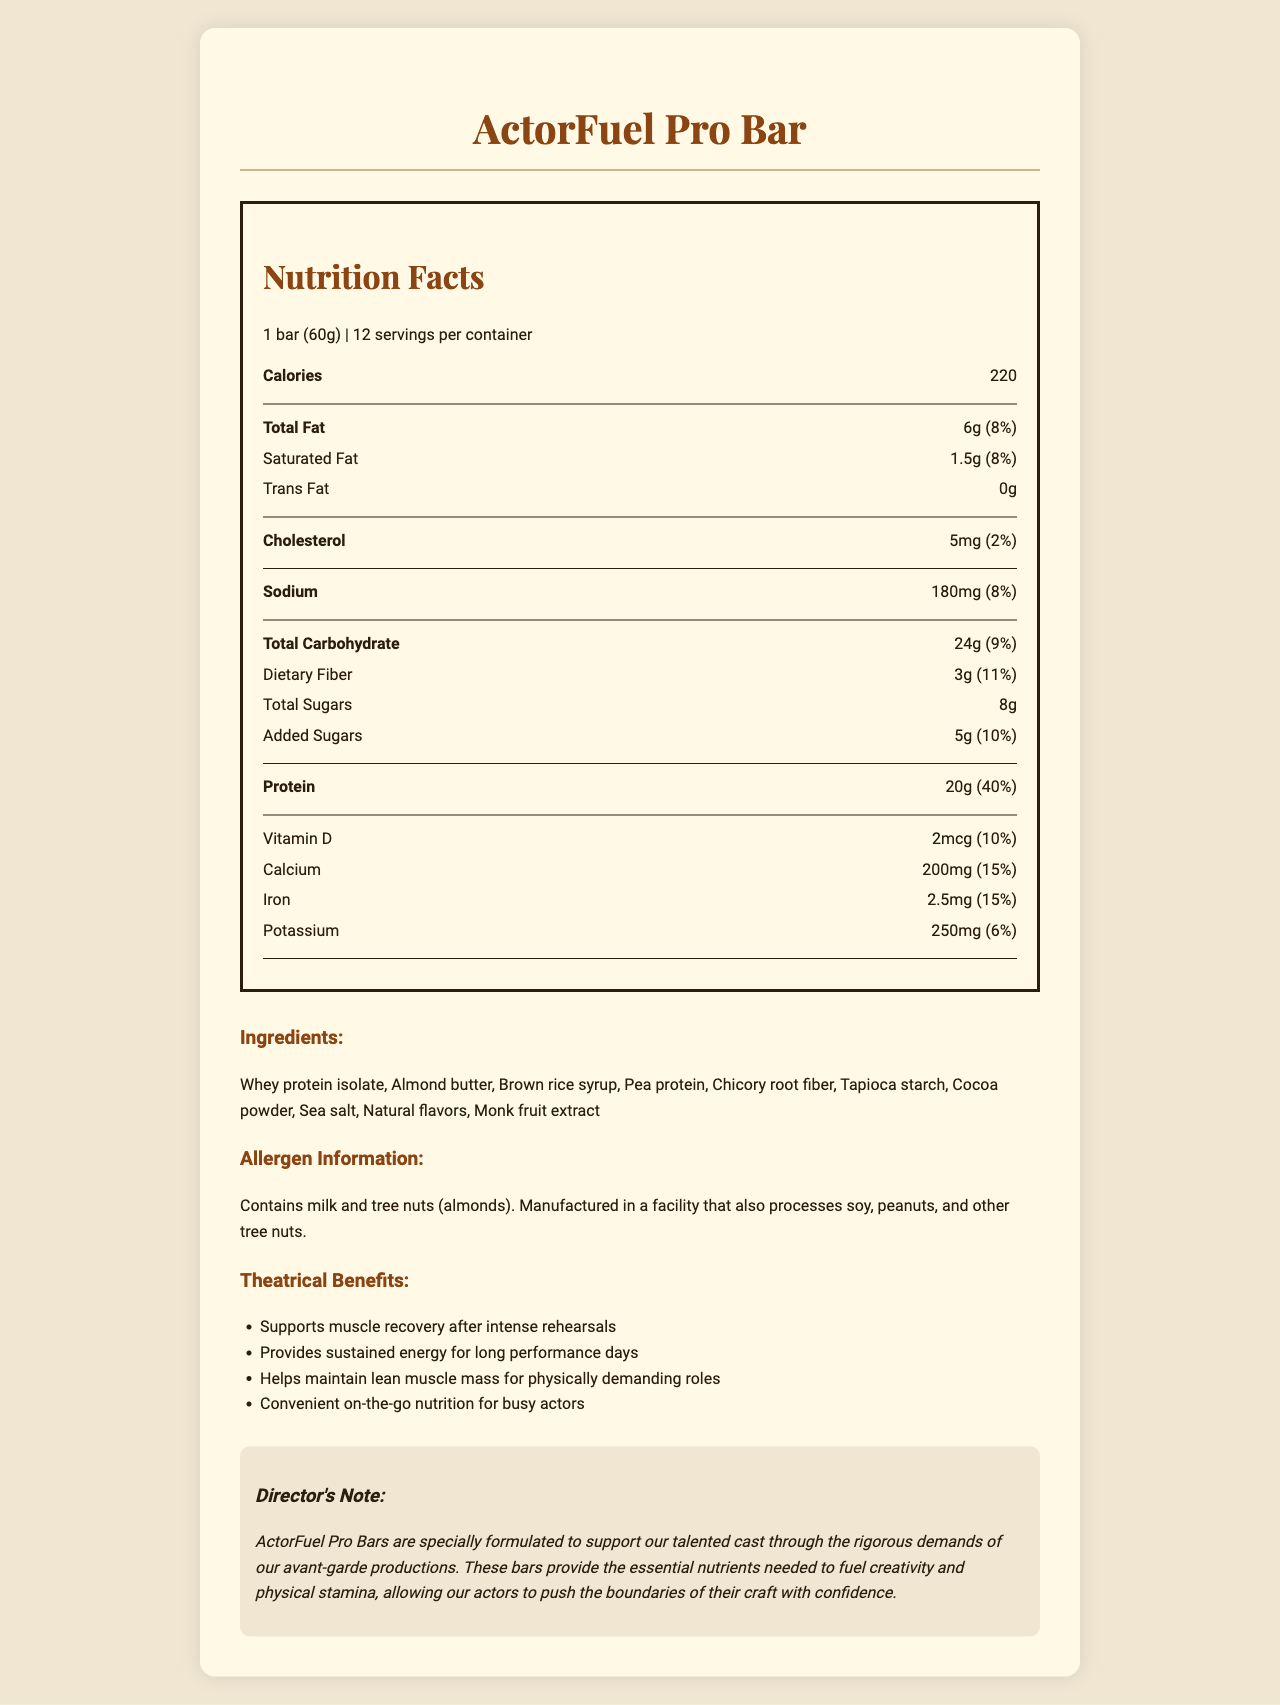what is the serving size of the ActorFuel Pro Bar? The serving size is clearly stated in the document as 1 bar (60g).
Answer: 1 bar (60g) how many servings are in each container of the ActorFuel Pro Bar? The document specifies that each container holds 12 servings.
Answer: 12 how much protein does each bar contain? The document lists the protein content as 20g per serving.
Answer: 20g What is the primary protein source listed in the ingredients? In the ingredients list, whey protein isolate is the primary source of protein.
Answer: Whey protein isolate What is the total amount of carbohydrates in one serving of the ActorFuel Pro Bar? The total carbohydrate content per serving is stated as 24g.
Answer: 24g how much dietary fiber is in one serving of the bar? The dietary fiber content is given as 3g per serving.
Answer: 3g what percentage of daily value of protein does the bar provide? The document lists the daily value percentage of protein as 40%.
Answer: 40% which of the following ingredients is NOT in the ActorFuel Pro Bar? A. Almond butter B. Pea protein C. Soy Protein The ingredient list includes almond butter and pea protein, but not soy protein.
Answer: C. Soy Protein What amount of Potassium does each serving of the ActorFuel Pro Bar contain? A. 200mg B. 250mg C. 300mg The document states that each serving contains 250mg of potassium.
Answer: B True or False: The ActorFuel Pro Bar contains trans fat. The document specifically lists trans fat as 0g, meaning it does not contain trans fat.
Answer: False Summarize the main idea of the document. The document focuses on how the ActorFuel Pro Bar is designed to fuel and support actors with essential nutrients, detailing its nutrition content, ingredients, and specific benefits for theatrical performance.
Answer: The document provides the nutrition facts for ActorFuel Pro Bar, highlighting its high protein and low-fat content, intended to support actors' physically demanding roles. It lists the nutrients, ingredients, allergen information, and theatrical benefits to illustrate how the bar maintains energy and muscle recovery for actors. Is there information on the price of the ActorFuel Pro Bar? The document focuses on the nutritional content, ingredients, and benefits for actors but does not provide any information on pricing.
Answer: Not enough information 